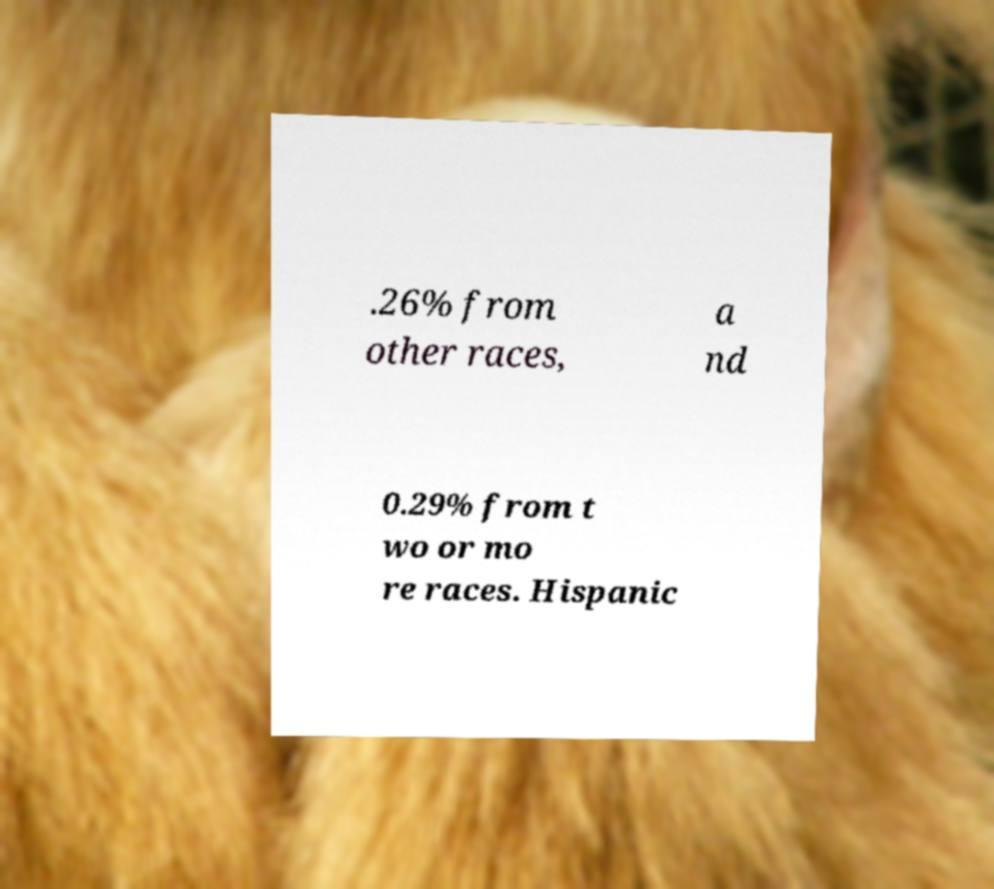I need the written content from this picture converted into text. Can you do that? .26% from other races, a nd 0.29% from t wo or mo re races. Hispanic 